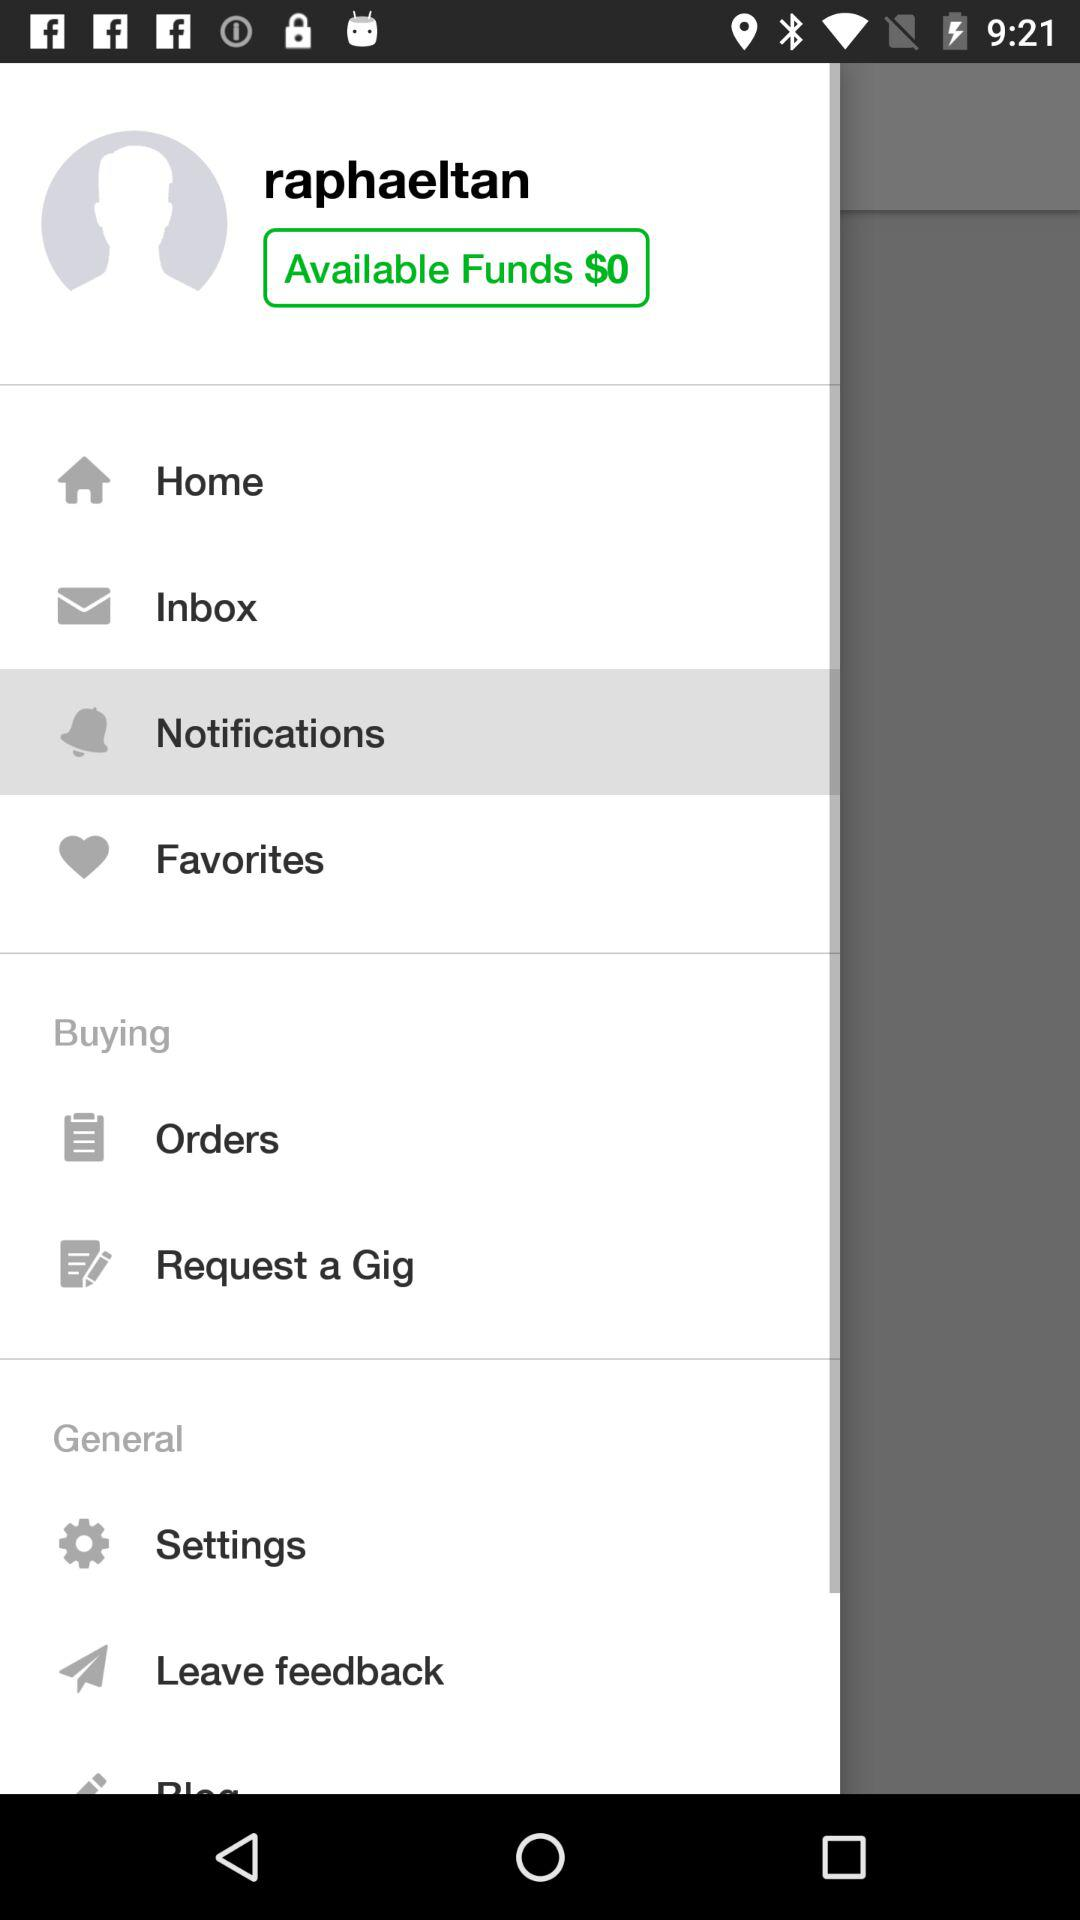How much money do I have available?
Answer the question using a single word or phrase. $0 